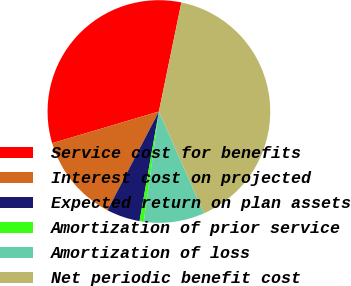<chart> <loc_0><loc_0><loc_500><loc_500><pie_chart><fcel>Service cost for benefits<fcel>Interest cost on projected<fcel>Expected return on plan assets<fcel>Amortization of prior service<fcel>Amortization of loss<fcel>Net periodic benefit cost<nl><fcel>32.83%<fcel>12.77%<fcel>4.86%<fcel>0.61%<fcel>8.81%<fcel>40.12%<nl></chart> 